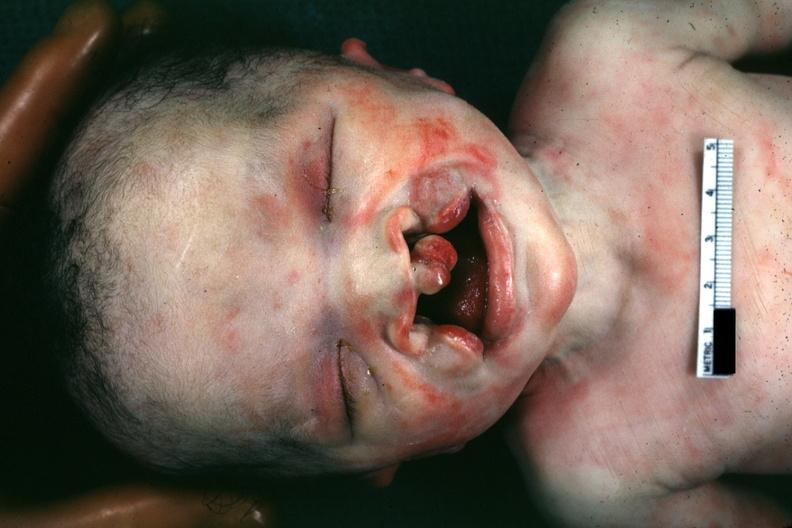s vessel present?
Answer the question using a single word or phrase. No 